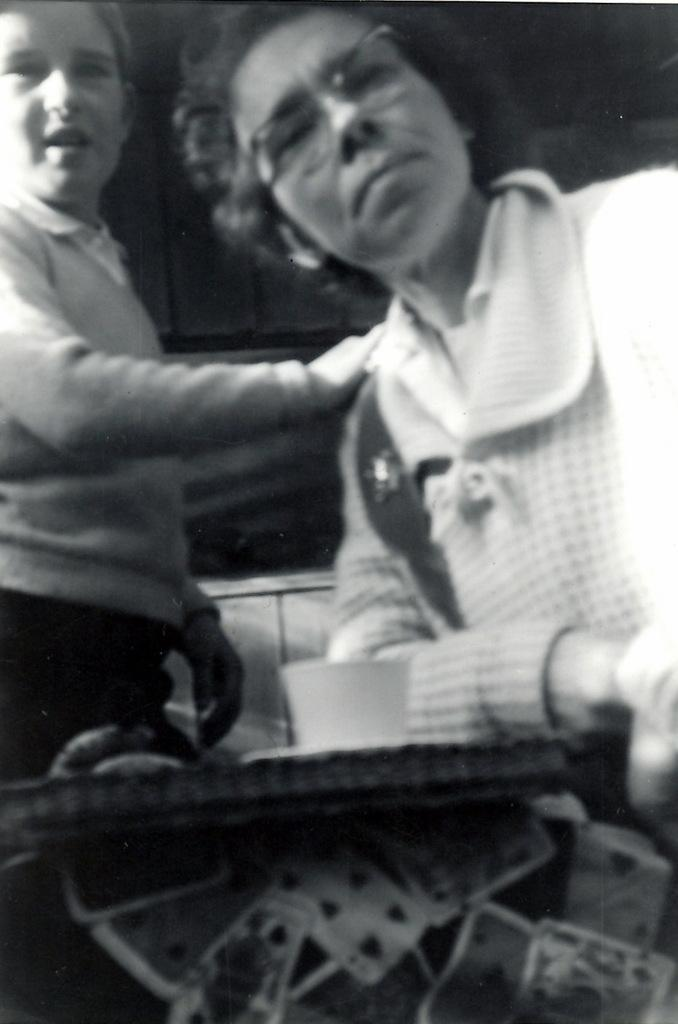How many people are present in the image? There are two members in the image. What is the main object in the image besides the people? There is a table in the image. What is placed on the table? A cup is placed on the table. What is the color scheme of the image? The image is black and white. How many pigs can be seen in the image? There are no pigs present in the image. Is there a crib visible in the image? There is no crib present in the image. 